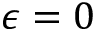<formula> <loc_0><loc_0><loc_500><loc_500>\epsilon = 0</formula> 